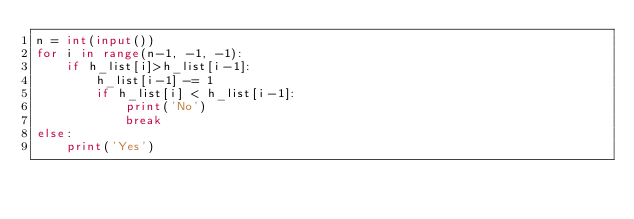Convert code to text. <code><loc_0><loc_0><loc_500><loc_500><_Python_>n = int(input())
for i in range(n-1, -1, -1):
    if h_list[i]>h_list[i-1]:
        h_list[i-1] -= 1
        if h_list[i] < h_list[i-1]:
            print('No')
            break
else:
    print('Yes')</code> 